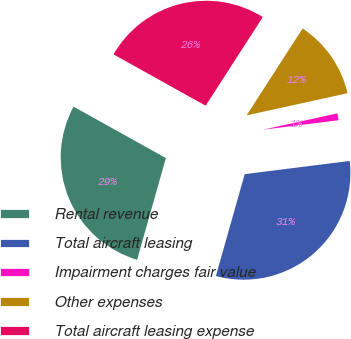<chart> <loc_0><loc_0><loc_500><loc_500><pie_chart><fcel>Rental revenue<fcel>Total aircraft leasing<fcel>Impairment charges fair value<fcel>Other expenses<fcel>Total aircraft leasing expense<nl><fcel>28.7%<fcel>31.38%<fcel>1.45%<fcel>12.45%<fcel>26.02%<nl></chart> 